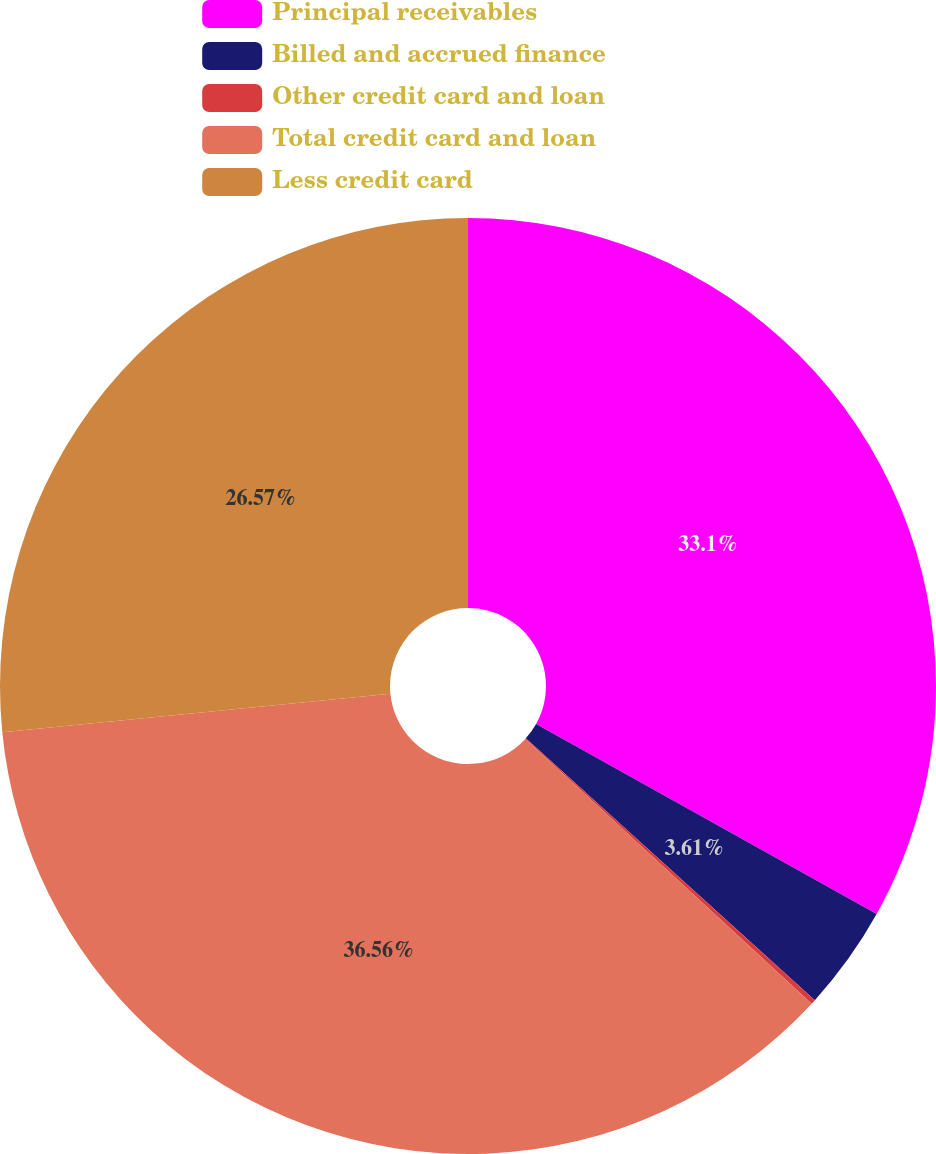Convert chart. <chart><loc_0><loc_0><loc_500><loc_500><pie_chart><fcel>Principal receivables<fcel>Billed and accrued finance<fcel>Other credit card and loan<fcel>Total credit card and loan<fcel>Less credit card<nl><fcel>33.1%<fcel>3.61%<fcel>0.16%<fcel>36.55%<fcel>26.57%<nl></chart> 